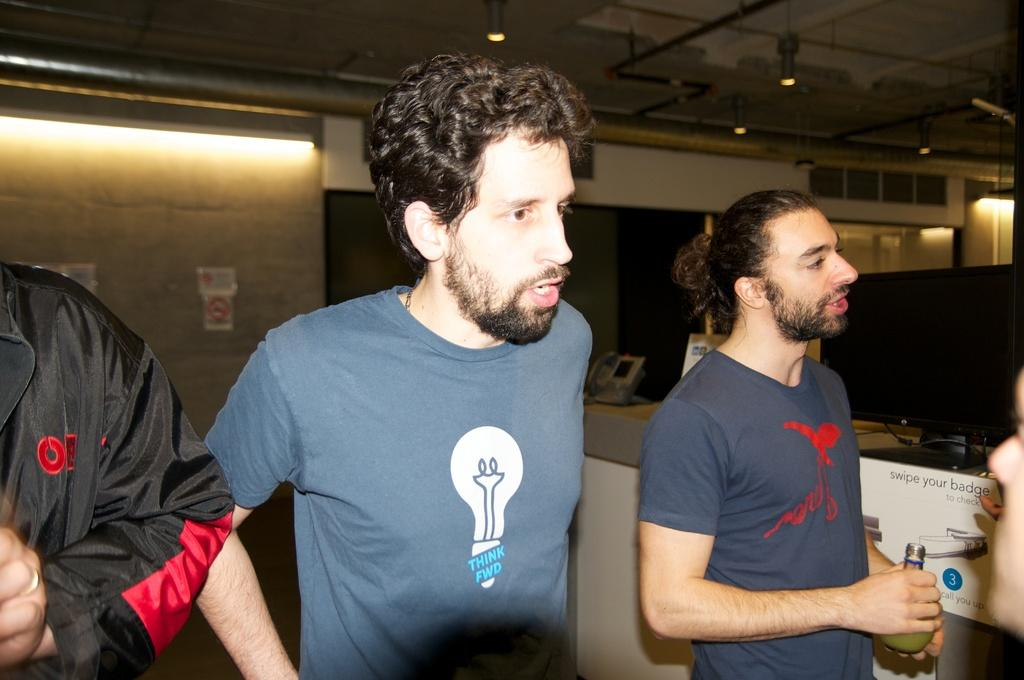<image>
Describe the image concisely. The man in the middle is wearing a Think Fwd t-shirt with a picture of a light bulb. 